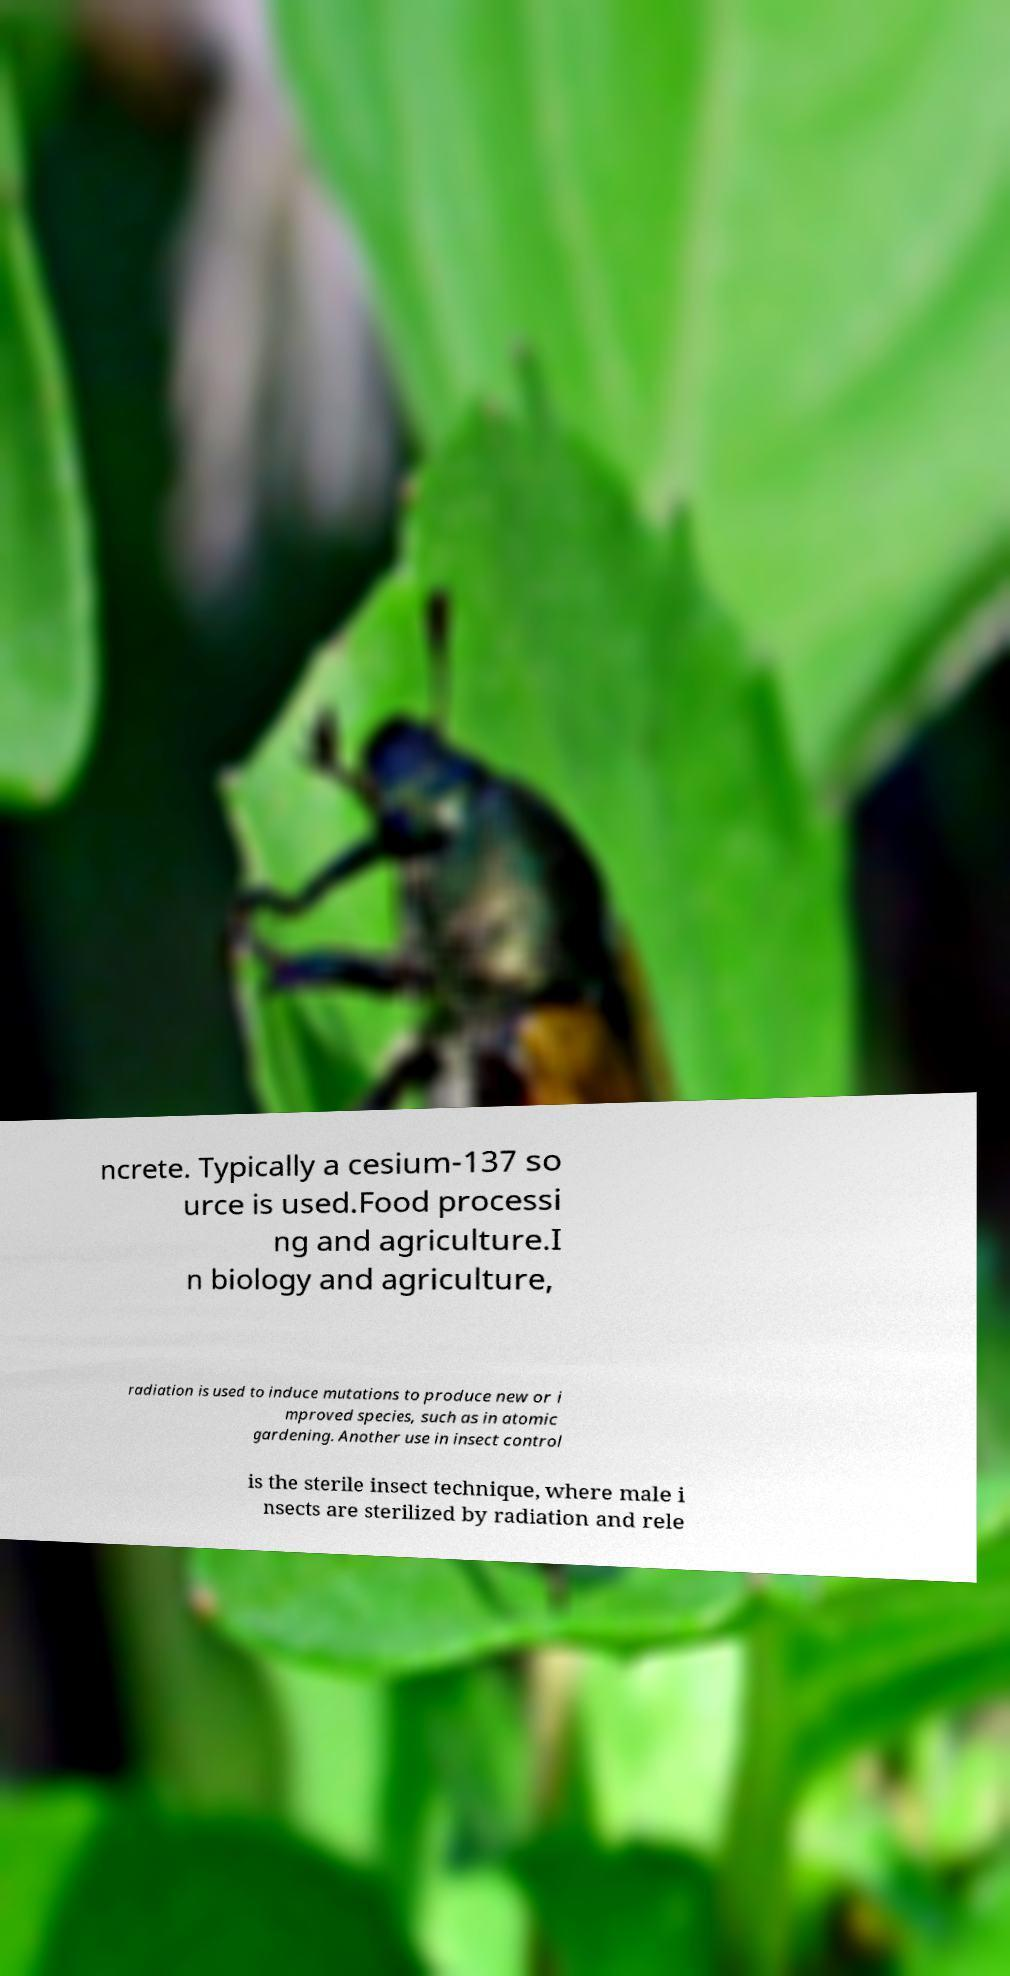Could you extract and type out the text from this image? ncrete. Typically a cesium-137 so urce is used.Food processi ng and agriculture.I n biology and agriculture, radiation is used to induce mutations to produce new or i mproved species, such as in atomic gardening. Another use in insect control is the sterile insect technique, where male i nsects are sterilized by radiation and rele 